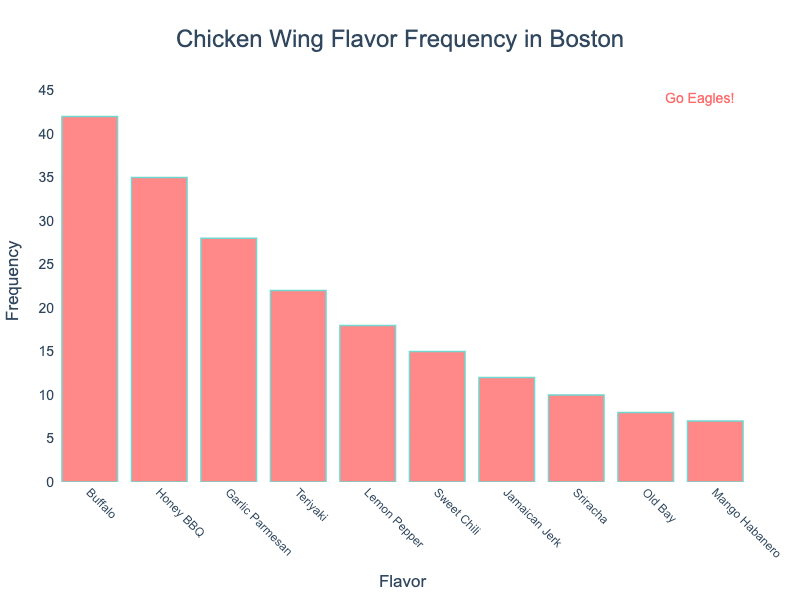What is the most popular chicken wing flavor in Boston? The most popular chicken wing flavor will have the highest bar in the histogram. The tallest bar corresponds to "Buffalo" with a frequency of 42.
Answer: Buffalo What is the least popular chicken wing flavor in Boston? The least popular chicken wing flavor will have the shortest bar in the histogram. The shortest bar corresponds to "Mango Habanero" with a frequency of 7.
Answer: Mango Habanero How many flavors have a frequency greater than 20? To answer this, count all the bars with heights exceeding 20. These are "Buffalo," "Honey BBQ," "Garlic Parmesan," and "Teriyaki," which are four flavors.
Answer: 4 Which flavors have a frequency between 10 and 20? To find this, identify the bars whose heights fall between 10 and 20. These flavors are "Lemon Pepper," "Sweet Chili," and "Jamaican Jerk."
Answer: Lemon Pepper, Sweet Chili, Jamaican Jerk What is the total frequency of all the chicken wing flavors combined? Sum the frequencies of all the flavors to get the total. 42 + 35 + 28 + 22 + 18 + 15 + 12 + 10 + 8 + 7 = 197.
Answer: 197 Which flavor ranks third in popularity, and what is its frequency? To find the third most popular flavor, look for the third tallest bar. "Garlic Parmesan" is the third highest with a frequency of 28.
Answer: Garlic Parmesan, 28 How much more popular is Buffalo compared to Sriracha? Subtract the frequency of Sriracha from Buffalo. Buffalo has 42, and Sriracha has 10. The difference is 42 - 10 = 32.
Answer: 32 What’s the average frequency of the top 5 most popular flavors? First, identify the top 5 most popular flavors: Buffalo, Honey BBQ, Garlic Parmesan, Teriyaki, and Lemon Pepper. Sum their frequencies: 42 + 35 + 28 + 22 + 18 = 145. Divide by 5 to get the average: 145 / 5 = 29.
Answer: 29 How many flavors are displayed in the histogram? Count the number of distinct bars to find the total number of flavors displayed. There are ten bars in the histogram.
Answer: 10 